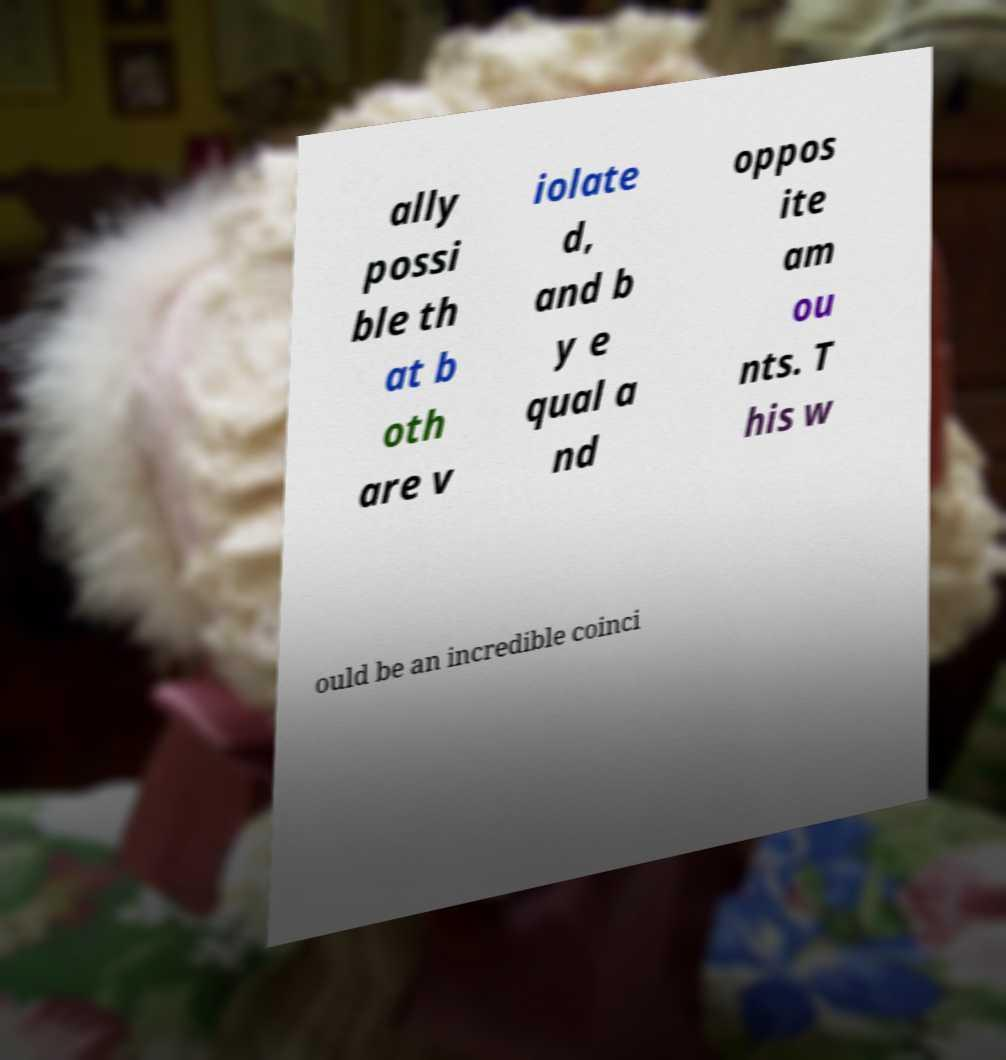For documentation purposes, I need the text within this image transcribed. Could you provide that? ally possi ble th at b oth are v iolate d, and b y e qual a nd oppos ite am ou nts. T his w ould be an incredible coinci 